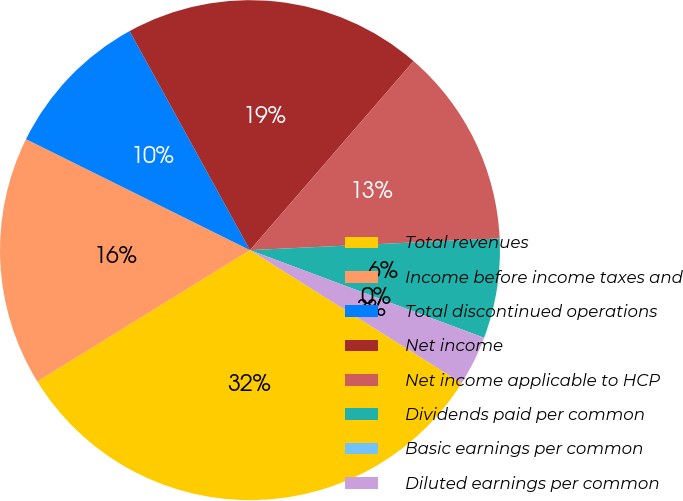Convert chart to OTSL. <chart><loc_0><loc_0><loc_500><loc_500><pie_chart><fcel>Total revenues<fcel>Income before income taxes and<fcel>Total discontinued operations<fcel>Net income<fcel>Net income applicable to HCP<fcel>Dividends paid per common<fcel>Basic earnings per common<fcel>Diluted earnings per common<nl><fcel>32.26%<fcel>16.13%<fcel>9.68%<fcel>19.35%<fcel>12.9%<fcel>6.45%<fcel>0.0%<fcel>3.23%<nl></chart> 